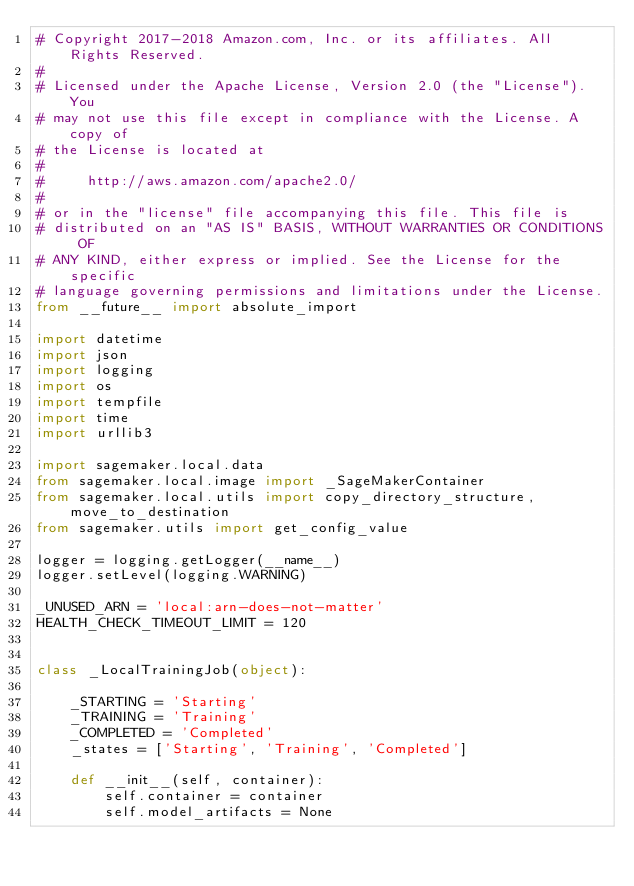<code> <loc_0><loc_0><loc_500><loc_500><_Python_># Copyright 2017-2018 Amazon.com, Inc. or its affiliates. All Rights Reserved.
#
# Licensed under the Apache License, Version 2.0 (the "License"). You
# may not use this file except in compliance with the License. A copy of
# the License is located at
#
#     http://aws.amazon.com/apache2.0/
#
# or in the "license" file accompanying this file. This file is
# distributed on an "AS IS" BASIS, WITHOUT WARRANTIES OR CONDITIONS OF
# ANY KIND, either express or implied. See the License for the specific
# language governing permissions and limitations under the License.
from __future__ import absolute_import

import datetime
import json
import logging
import os
import tempfile
import time
import urllib3

import sagemaker.local.data
from sagemaker.local.image import _SageMakerContainer
from sagemaker.local.utils import copy_directory_structure, move_to_destination
from sagemaker.utils import get_config_value

logger = logging.getLogger(__name__)
logger.setLevel(logging.WARNING)

_UNUSED_ARN = 'local:arn-does-not-matter'
HEALTH_CHECK_TIMEOUT_LIMIT = 120


class _LocalTrainingJob(object):

    _STARTING = 'Starting'
    _TRAINING = 'Training'
    _COMPLETED = 'Completed'
    _states = ['Starting', 'Training', 'Completed']

    def __init__(self, container):
        self.container = container
        self.model_artifacts = None</code> 